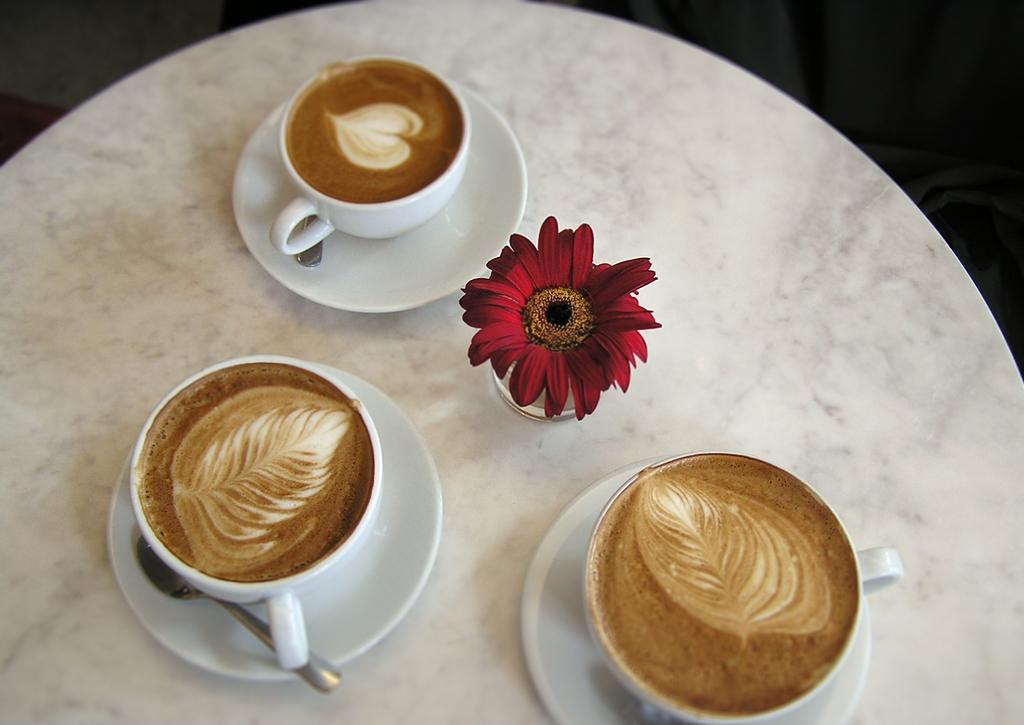What type of table is in the image? There is a white table in the image. What items can be seen on the table? There are cups, saucers, spoons, and a glass on the table. What is visible inside the cups? Coffee is visible in the image. What color is the flower in the image? There is a red flower in the image. How many friends are sitting at the table in the image? There is no information about friends in the image; it only shows a table with various items on it. 